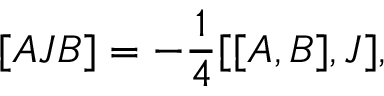<formula> <loc_0><loc_0><loc_500><loc_500>[ A J B ] = - \frac { 1 } { 4 } [ [ A , B ] , J ] ,</formula> 